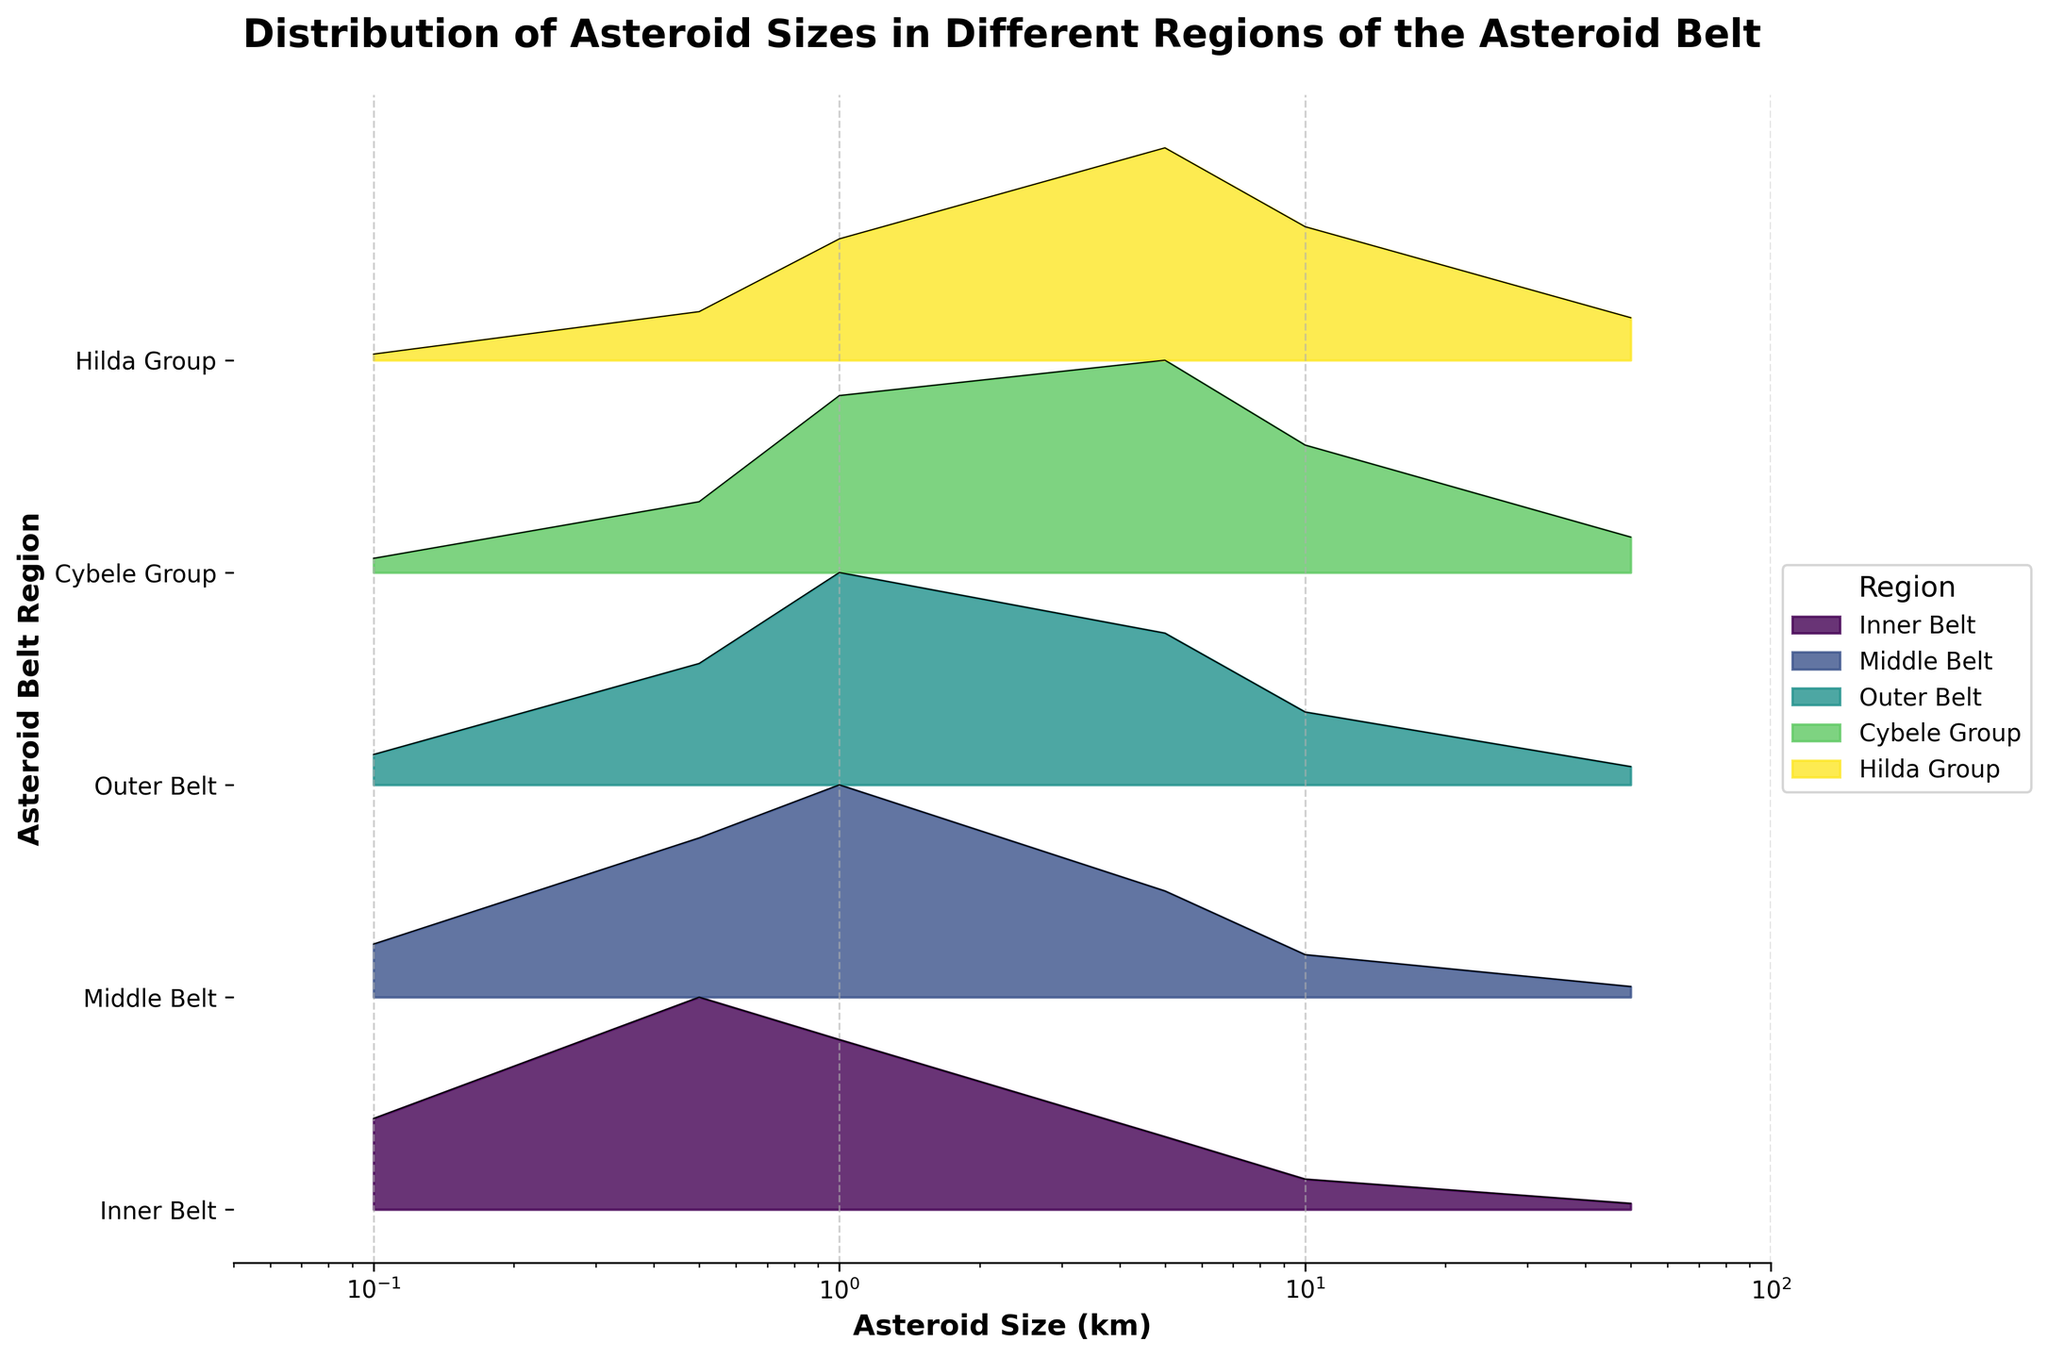What's the title of the plot? The title of the plot is displayed on top and reads "Distribution of Asteroid Sizes in Different Regions of the Asteroid Belt".
Answer: Distribution of Asteroid Sizes in Different Regions of the Asteroid Belt What type of plot is used in the figure? The plot uses overlapping area plots, commonly known as a Ridgeline plot, where each region’s distribution is displayed as a filled area.
Answer: Ridgeline plot Which region has the highest frequency for asteroid sizes around 1 km? By observing the height of the area for the 1 km size, the Middle Belt has the highest frequency compared to other regions.
Answer: Middle Belt Which asteroid belt region has the highest general frequency of large asteroids (e.g., 50 km)? The highest filled area for the 50 km size can be seen in the Hilda Group.
Answer: Hilda Group List all the regions included in the plot. Each region has its own filled area; the labels on the y-axis list all regions as Inner Belt, Middle Belt, Outer Belt, Cybele Group, and Hilda Group.
Answer: Inner Belt, Middle Belt, Outer Belt, Cybele Group, Hilda Group Which region shows the widest range of asteroid sizes? By looking at the x-axis and the width of the filled areas, all regions show sizes ranging from 0.1 km to 50 km, so each region covers the same range of sizes.
Answer: All regions cover the same range How many regions display a peak for asteroids of about 5 km in size? Reviewing the height of the areas around 5 km for each region, it is evident that all five regions display a significant peak around this size.
Answer: Five regions What is the general trend in the frequency of smaller (0.1 km) versus larger (10 km) asteroids across the regions? Smaller asteroids (0.1 km) generally have higher frequencies, shown by taller areas, whereas larger asteroids (10 km) have lower frequencies with shorter areas in all regions.
Answer: Smaller asteroids are more frequent than larger asteroids Which region has the least number of small asteroids (0.1 km)? By comparing the height of the filled areas at the 0.1 km mark, the Hilda Group has the smallest area, indicating the least number of small asteroids.
Answer: Hilda Group How does the distribution of asteroid sizes in the Cybele Group compare to the Outer Belt? Observing both areas, the Cybele Group has fewer small asteroids (0.1 km) and more large asteroids (5 km and above) compared to the Outer Belt, which shows more smaller asteroids and fewer larger ones.
Answer: The Cybele Group has fewer small but more large asteroids than the Outer Belt 